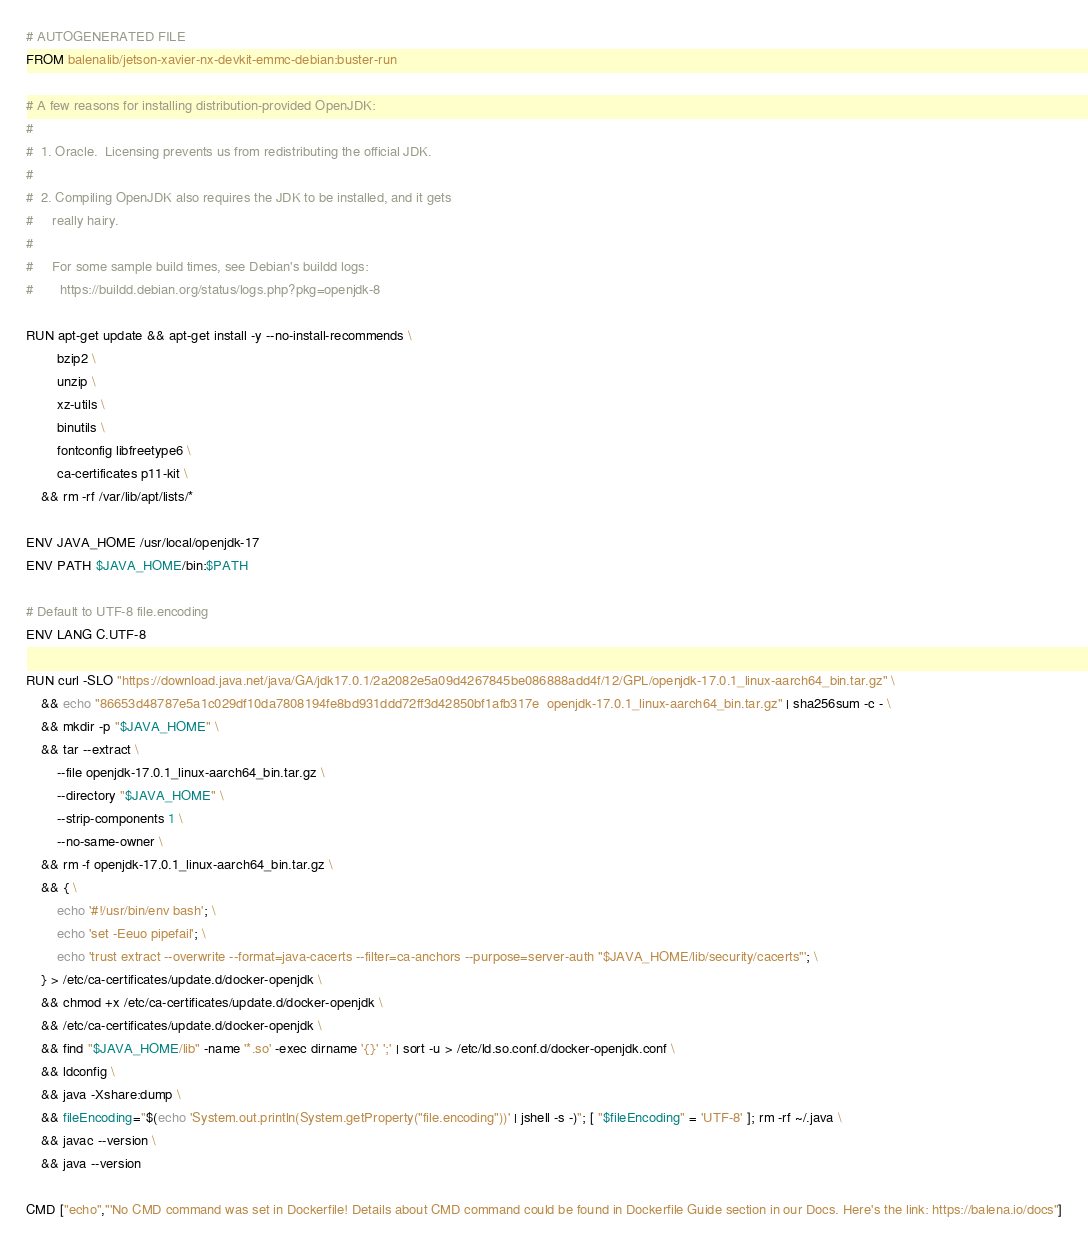Convert code to text. <code><loc_0><loc_0><loc_500><loc_500><_Dockerfile_># AUTOGENERATED FILE
FROM balenalib/jetson-xavier-nx-devkit-emmc-debian:buster-run

# A few reasons for installing distribution-provided OpenJDK:
#
#  1. Oracle.  Licensing prevents us from redistributing the official JDK.
#
#  2. Compiling OpenJDK also requires the JDK to be installed, and it gets
#     really hairy.
#
#     For some sample build times, see Debian's buildd logs:
#       https://buildd.debian.org/status/logs.php?pkg=openjdk-8

RUN apt-get update && apt-get install -y --no-install-recommends \
		bzip2 \
		unzip \
		xz-utils \
		binutils \
		fontconfig libfreetype6 \
		ca-certificates p11-kit \
	&& rm -rf /var/lib/apt/lists/*

ENV JAVA_HOME /usr/local/openjdk-17
ENV PATH $JAVA_HOME/bin:$PATH

# Default to UTF-8 file.encoding
ENV LANG C.UTF-8

RUN curl -SLO "https://download.java.net/java/GA/jdk17.0.1/2a2082e5a09d4267845be086888add4f/12/GPL/openjdk-17.0.1_linux-aarch64_bin.tar.gz" \
	&& echo "86653d48787e5a1c029df10da7808194fe8bd931ddd72ff3d42850bf1afb317e  openjdk-17.0.1_linux-aarch64_bin.tar.gz" | sha256sum -c - \
	&& mkdir -p "$JAVA_HOME" \
	&& tar --extract \
		--file openjdk-17.0.1_linux-aarch64_bin.tar.gz \
		--directory "$JAVA_HOME" \
		--strip-components 1 \
		--no-same-owner \
	&& rm -f openjdk-17.0.1_linux-aarch64_bin.tar.gz \
	&& { \
		echo '#!/usr/bin/env bash'; \
		echo 'set -Eeuo pipefail'; \
		echo 'trust extract --overwrite --format=java-cacerts --filter=ca-anchors --purpose=server-auth "$JAVA_HOME/lib/security/cacerts"'; \
	} > /etc/ca-certificates/update.d/docker-openjdk \
	&& chmod +x /etc/ca-certificates/update.d/docker-openjdk \
	&& /etc/ca-certificates/update.d/docker-openjdk \
	&& find "$JAVA_HOME/lib" -name '*.so' -exec dirname '{}' ';' | sort -u > /etc/ld.so.conf.d/docker-openjdk.conf \
	&& ldconfig \
	&& java -Xshare:dump \
	&& fileEncoding="$(echo 'System.out.println(System.getProperty("file.encoding"))' | jshell -s -)"; [ "$fileEncoding" = 'UTF-8' ]; rm -rf ~/.java \
	&& javac --version \
	&& java --version

CMD ["echo","'No CMD command was set in Dockerfile! Details about CMD command could be found in Dockerfile Guide section in our Docs. Here's the link: https://balena.io/docs"]
</code> 